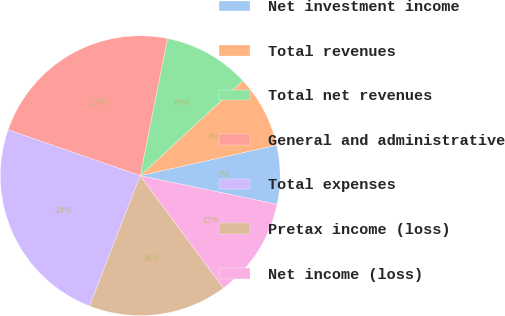Convert chart to OTSL. <chart><loc_0><loc_0><loc_500><loc_500><pie_chart><fcel>Net investment income<fcel>Total revenues<fcel>Total net revenues<fcel>General and administrative<fcel>Total expenses<fcel>Pretax income (loss)<fcel>Net income (loss)<nl><fcel>6.78%<fcel>8.38%<fcel>9.99%<fcel>22.81%<fcel>24.41%<fcel>16.03%<fcel>11.59%<nl></chart> 